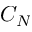<formula> <loc_0><loc_0><loc_500><loc_500>C _ { N }</formula> 